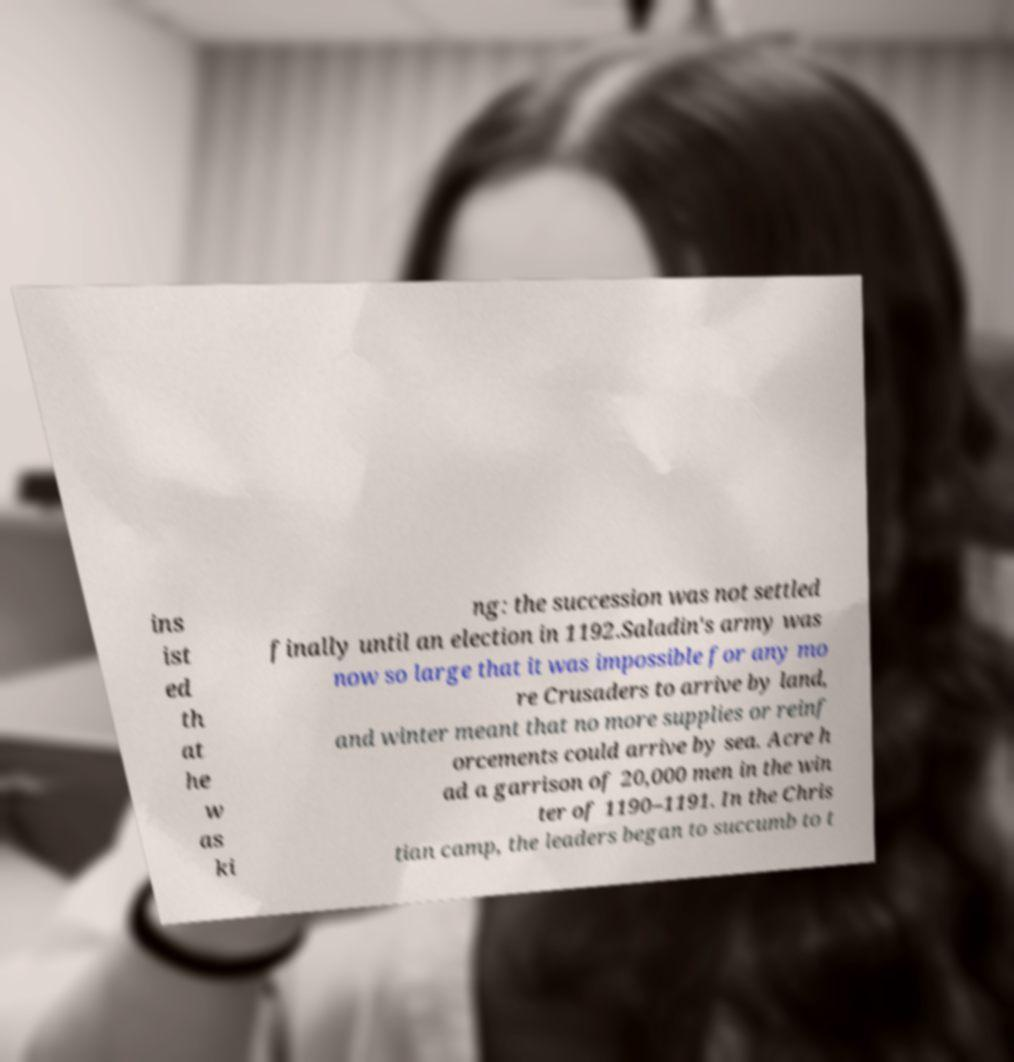Please identify and transcribe the text found in this image. ins ist ed th at he w as ki ng: the succession was not settled finally until an election in 1192.Saladin's army was now so large that it was impossible for any mo re Crusaders to arrive by land, and winter meant that no more supplies or reinf orcements could arrive by sea. Acre h ad a garrison of 20,000 men in the win ter of 1190–1191. In the Chris tian camp, the leaders began to succumb to t 